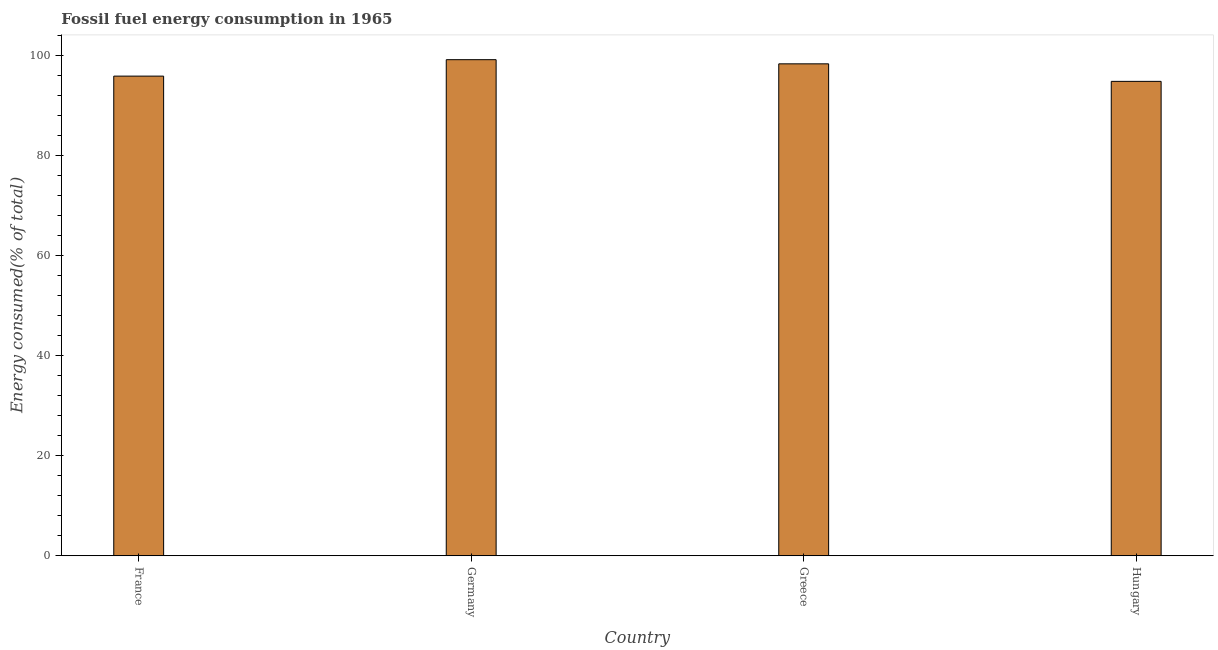Does the graph contain any zero values?
Keep it short and to the point. No. Does the graph contain grids?
Your answer should be very brief. No. What is the title of the graph?
Keep it short and to the point. Fossil fuel energy consumption in 1965. What is the label or title of the X-axis?
Your response must be concise. Country. What is the label or title of the Y-axis?
Keep it short and to the point. Energy consumed(% of total). What is the fossil fuel energy consumption in France?
Keep it short and to the point. 95.82. Across all countries, what is the maximum fossil fuel energy consumption?
Offer a very short reply. 99.1. Across all countries, what is the minimum fossil fuel energy consumption?
Offer a terse response. 94.77. In which country was the fossil fuel energy consumption minimum?
Ensure brevity in your answer.  Hungary. What is the sum of the fossil fuel energy consumption?
Provide a short and direct response. 387.96. What is the difference between the fossil fuel energy consumption in France and Germany?
Provide a succinct answer. -3.28. What is the average fossil fuel energy consumption per country?
Your response must be concise. 96.99. What is the median fossil fuel energy consumption?
Your answer should be compact. 97.05. In how many countries, is the fossil fuel energy consumption greater than 48 %?
Your answer should be compact. 4. What is the ratio of the fossil fuel energy consumption in Greece to that in Hungary?
Make the answer very short. 1.04. Is the fossil fuel energy consumption in France less than that in Hungary?
Keep it short and to the point. No. What is the difference between the highest and the second highest fossil fuel energy consumption?
Provide a succinct answer. 0.83. What is the difference between the highest and the lowest fossil fuel energy consumption?
Offer a terse response. 4.33. What is the difference between two consecutive major ticks on the Y-axis?
Keep it short and to the point. 20. Are the values on the major ticks of Y-axis written in scientific E-notation?
Make the answer very short. No. What is the Energy consumed(% of total) in France?
Make the answer very short. 95.82. What is the Energy consumed(% of total) of Germany?
Offer a very short reply. 99.1. What is the Energy consumed(% of total) in Greece?
Provide a short and direct response. 98.27. What is the Energy consumed(% of total) of Hungary?
Keep it short and to the point. 94.77. What is the difference between the Energy consumed(% of total) in France and Germany?
Offer a terse response. -3.28. What is the difference between the Energy consumed(% of total) in France and Greece?
Your response must be concise. -2.45. What is the difference between the Energy consumed(% of total) in France and Hungary?
Give a very brief answer. 1.05. What is the difference between the Energy consumed(% of total) in Germany and Greece?
Keep it short and to the point. 0.83. What is the difference between the Energy consumed(% of total) in Germany and Hungary?
Your response must be concise. 4.33. What is the difference between the Energy consumed(% of total) in Greece and Hungary?
Your answer should be compact. 3.5. What is the ratio of the Energy consumed(% of total) in France to that in Greece?
Ensure brevity in your answer.  0.97. What is the ratio of the Energy consumed(% of total) in Germany to that in Greece?
Ensure brevity in your answer.  1.01. What is the ratio of the Energy consumed(% of total) in Germany to that in Hungary?
Your response must be concise. 1.05. 